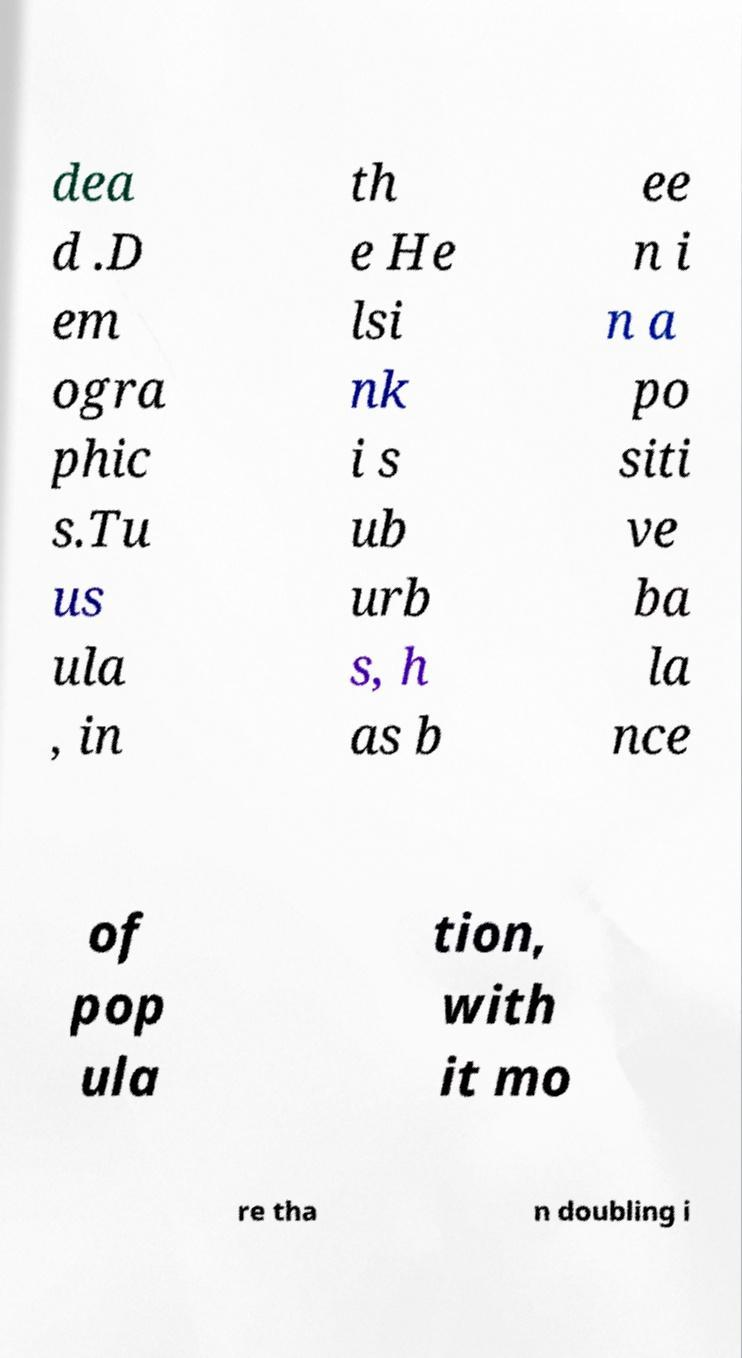Please identify and transcribe the text found in this image. dea d .D em ogra phic s.Tu us ula , in th e He lsi nk i s ub urb s, h as b ee n i n a po siti ve ba la nce of pop ula tion, with it mo re tha n doubling i 